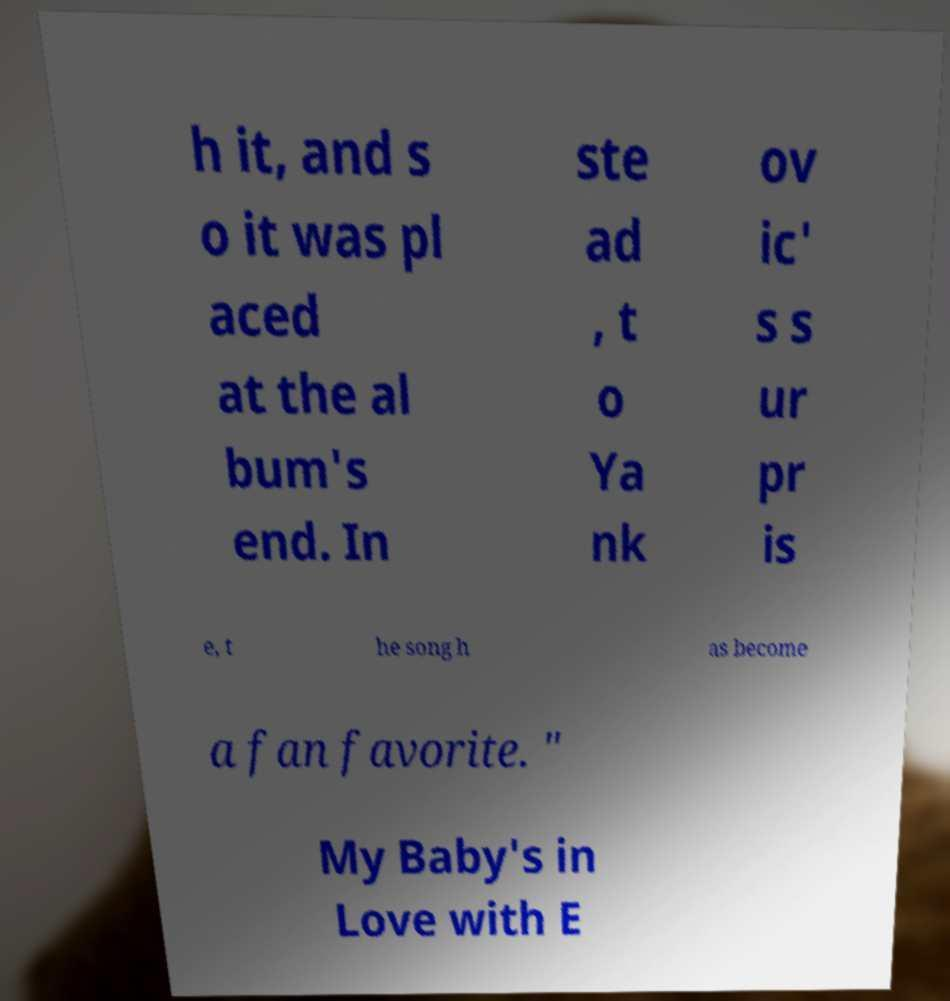Could you assist in decoding the text presented in this image and type it out clearly? h it, and s o it was pl aced at the al bum's end. In ste ad , t o Ya nk ov ic' s s ur pr is e, t he song h as become a fan favorite. " My Baby's in Love with E 